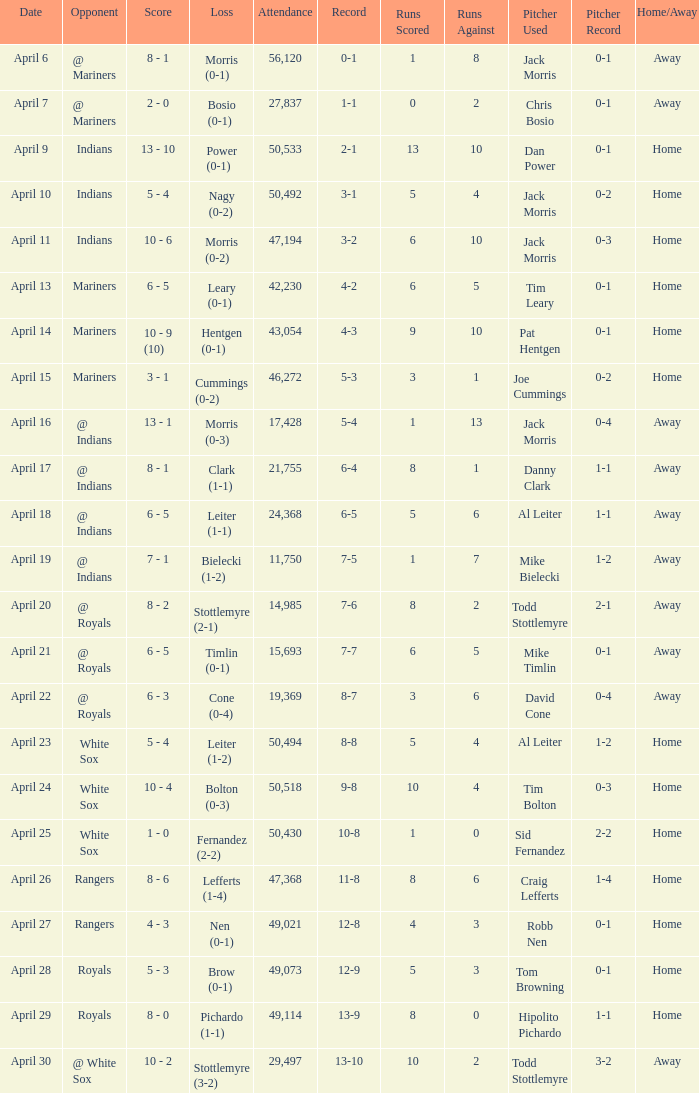On april 24, what score was documented? 10 - 4. 